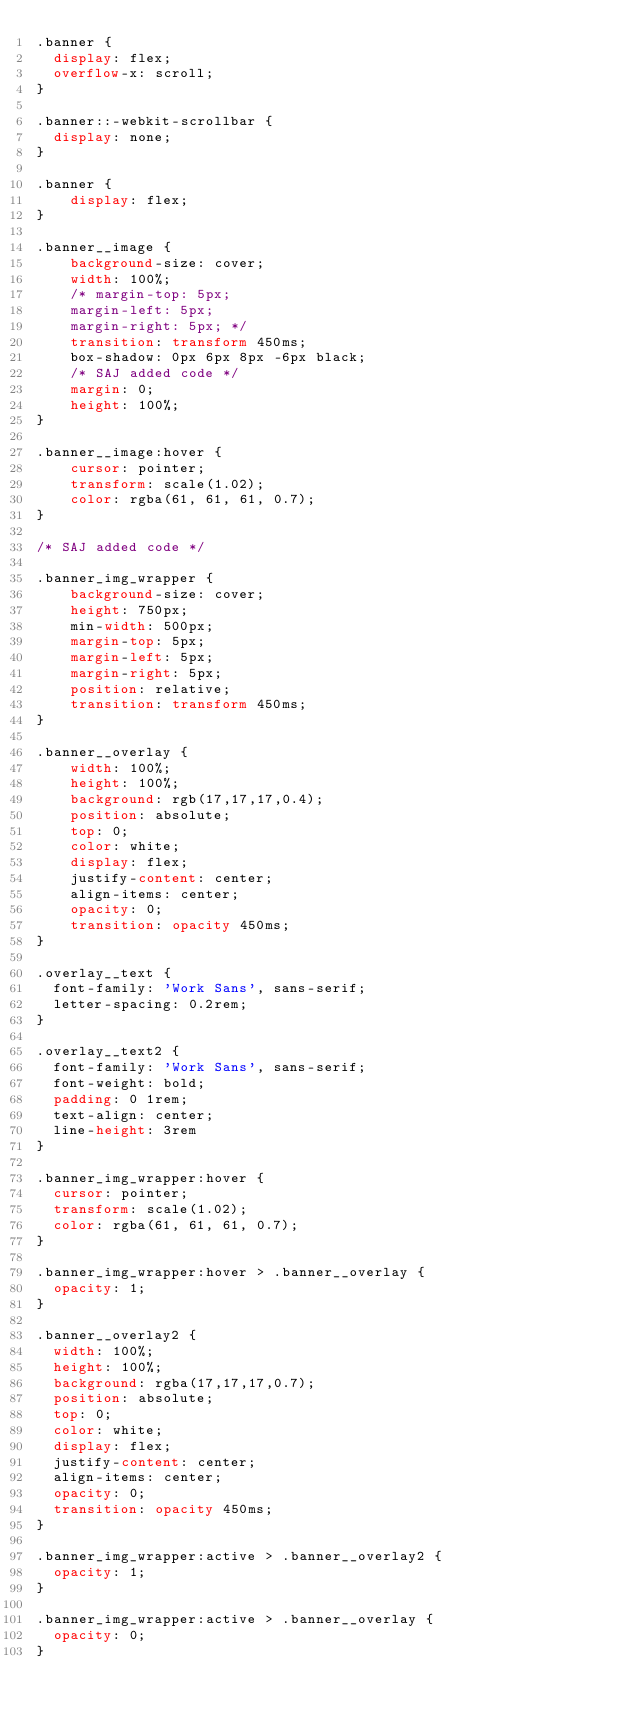Convert code to text. <code><loc_0><loc_0><loc_500><loc_500><_CSS_>.banner {
  display: flex;
  overflow-x: scroll;
}

.banner::-webkit-scrollbar {
  display: none;
}

.banner {
    display: flex;
}

.banner__image {
    background-size: cover;
    width: 100%;
    /* margin-top: 5px;
    margin-left: 5px;
    margin-right: 5px; */
    transition: transform 450ms;
    box-shadow: 0px 6px 8px -6px black;
    /* SAJ added code */
    margin: 0;
    height: 100%;
}

.banner__image:hover {
    cursor: pointer;
    transform: scale(1.02);
    color: rgba(61, 61, 61, 0.7);
}

/* SAJ added code */

.banner_img_wrapper { 
    background-size: cover;
    height: 750px;
    min-width: 500px;
    margin-top: 5px;
    margin-left: 5px;
    margin-right: 5px;
    position: relative;
    transition: transform 450ms;
}

.banner__overlay {
    width: 100%;
    height: 100%;
    background: rgb(17,17,17,0.4);
    position: absolute;
    top: 0;
    color: white;
    display: flex;
    justify-content: center;
    align-items: center;
    opacity: 0;
    transition: opacity 450ms;
}

.overlay__text {
  font-family: 'Work Sans', sans-serif;
  letter-spacing: 0.2rem;
}

.overlay__text2 {
  font-family: 'Work Sans', sans-serif;
  font-weight: bold;
  padding: 0 1rem;
  text-align: center;
  line-height: 3rem
}

.banner_img_wrapper:hover {
  cursor: pointer;
  transform: scale(1.02);
  color: rgba(61, 61, 61, 0.7);
}

.banner_img_wrapper:hover > .banner__overlay {
  opacity: 1;
}

.banner__overlay2 {
  width: 100%;
  height: 100%;
  background: rgba(17,17,17,0.7);
  position: absolute;
  top: 0;
  color: white;
  display: flex;
  justify-content: center;
  align-items: center;
  opacity: 0;
  transition: opacity 450ms;
}

.banner_img_wrapper:active > .banner__overlay2 {
  opacity: 1;
}

.banner_img_wrapper:active > .banner__overlay {
  opacity: 0;
}</code> 